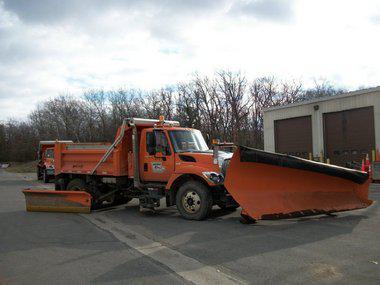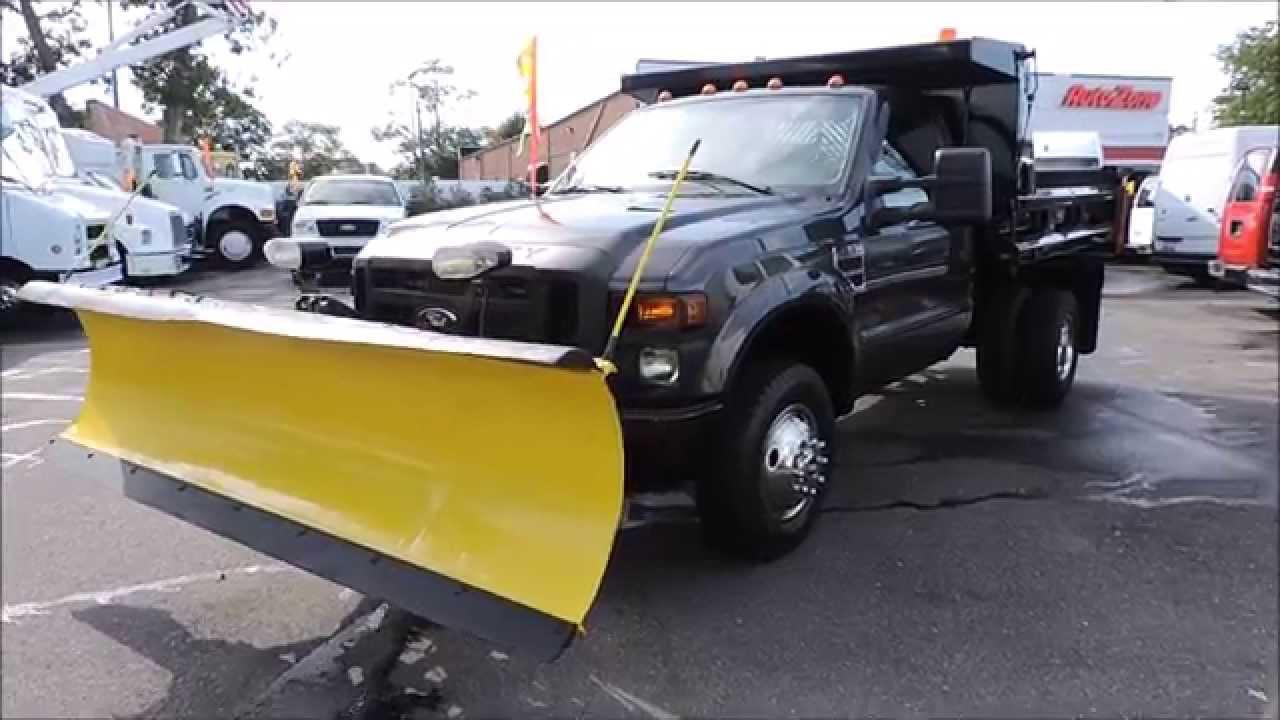The first image is the image on the left, the second image is the image on the right. Analyze the images presented: Is the assertion "An image shows a leftward-facing truck with a bright yellow plow." valid? Answer yes or no. Yes. 